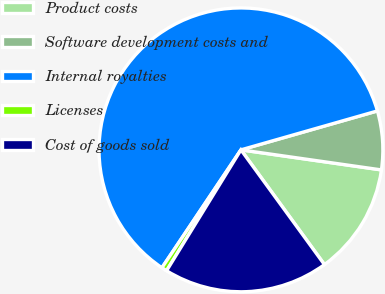<chart> <loc_0><loc_0><loc_500><loc_500><pie_chart><fcel>Product costs<fcel>Software development costs and<fcel>Internal royalties<fcel>Licenses<fcel>Cost of goods sold<nl><fcel>12.73%<fcel>6.68%<fcel>61.18%<fcel>0.62%<fcel>18.79%<nl></chart> 